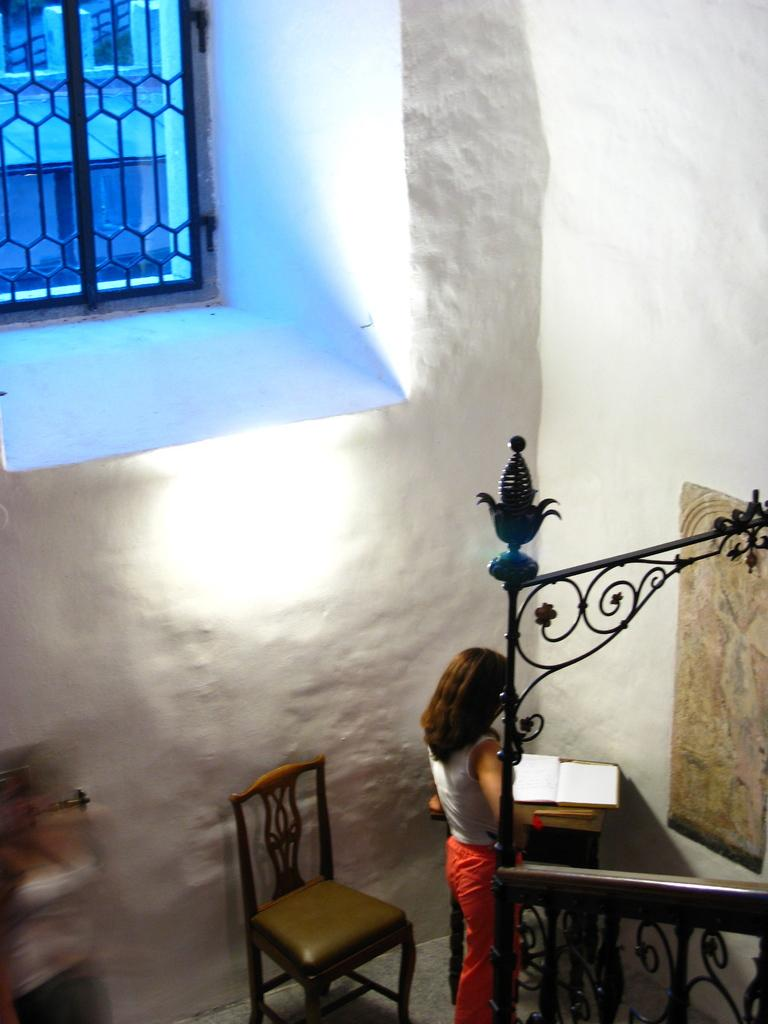What is the main subject in the image? There is a woman standing in the image. What furniture can be seen in the image? There is a chair and a stool in the image. What is placed on the stool? There is a book on the stool. What architectural features are present in the image? There is a wall and a window in the image. What type of truck can be seen parked near the window in the image? There is no truck present in the image; it only features a woman, a chair, a stool, a book, a wall, and a window. 